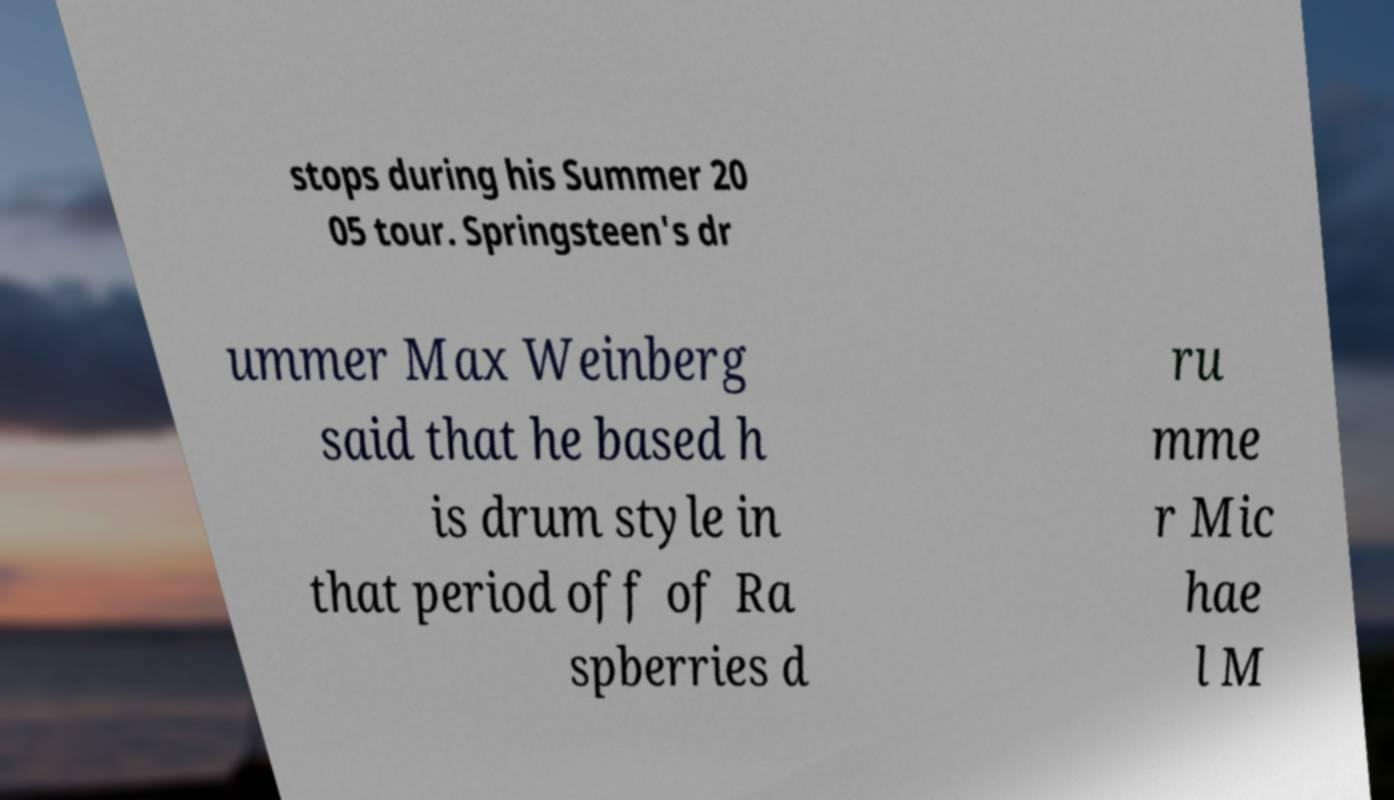Please read and relay the text visible in this image. What does it say? stops during his Summer 20 05 tour. Springsteen's dr ummer Max Weinberg said that he based h is drum style in that period off of Ra spberries d ru mme r Mic hae l M 